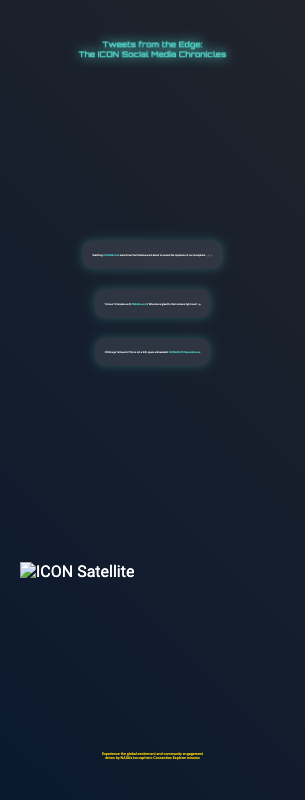what is the title of the book? The title is prominently displayed at the top of the cover in a large font.
Answer: Tweets from the Edge: The ICON Social Media Chronicles what are the hashtags in the tweets? The hashtags are included in the content of the tweets, emphasizing key themes of the mission.
Answer: #ICONMission, #NASALaunch, #ICONLiftoff, #SpaceScience what is the background color of the document? The background color contributes to the overall aesthetic of the cover, making it visually striking.
Answer: Black how many tweets are featured on the cover? The number of tweets can be counted visually in the presented social media mix.
Answer: Three what is the mood of the cover design? The design elements—colors and layout—create a specific feeling in the viewer.
Answer: Excitement what is the image displayed on the cover? The image relates directly to the mission and serves as a focal point on the cover.
Answer: ICON Satellite what kind of design style is used for the title? The font used for the title reflects a thematic connection to space science.
Answer: Futuristic what does the subtitle mention about community engagement? The subtitle encapsulates the essence of the social media-driven exploration of the mission.
Answer: Global excitement and community engagement what is the primary emotion conveyed by the tweets? The tweets collectively depict a strong sentiment that relates to the event being discussed.
Answer: Anticipation 